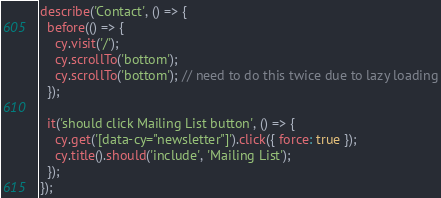Convert code to text. <code><loc_0><loc_0><loc_500><loc_500><_JavaScript_>describe('Contact', () => {
  before(() => {
    cy.visit('/');
    cy.scrollTo('bottom');
    cy.scrollTo('bottom'); // need to do this twice due to lazy loading
  });

  it('should click Mailing List button', () => {
    cy.get('[data-cy="newsletter"]').click({ force: true });
    cy.title().should('include', 'Mailing List');
  });
});
</code> 